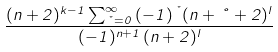Convert formula to latex. <formula><loc_0><loc_0><loc_500><loc_500>\frac { ( n + 2 ) ^ { k - 1 } \sum _ { \nu = 0 } ^ { \infty } \, ( - 1 ) ^ { \nu } ( n + \nu + 2 ) ^ { l } } { ( - 1 ) ^ { n + 1 } \, ( n + 2 ) ^ { l } }</formula> 